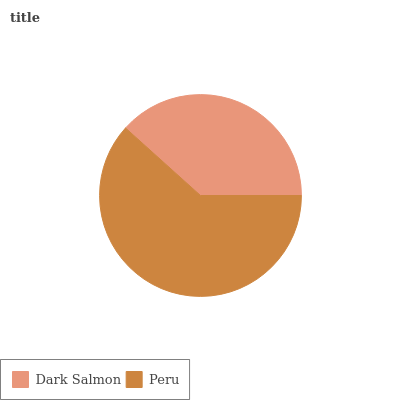Is Dark Salmon the minimum?
Answer yes or no. Yes. Is Peru the maximum?
Answer yes or no. Yes. Is Peru the minimum?
Answer yes or no. No. Is Peru greater than Dark Salmon?
Answer yes or no. Yes. Is Dark Salmon less than Peru?
Answer yes or no. Yes. Is Dark Salmon greater than Peru?
Answer yes or no. No. Is Peru less than Dark Salmon?
Answer yes or no. No. Is Peru the high median?
Answer yes or no. Yes. Is Dark Salmon the low median?
Answer yes or no. Yes. Is Dark Salmon the high median?
Answer yes or no. No. Is Peru the low median?
Answer yes or no. No. 